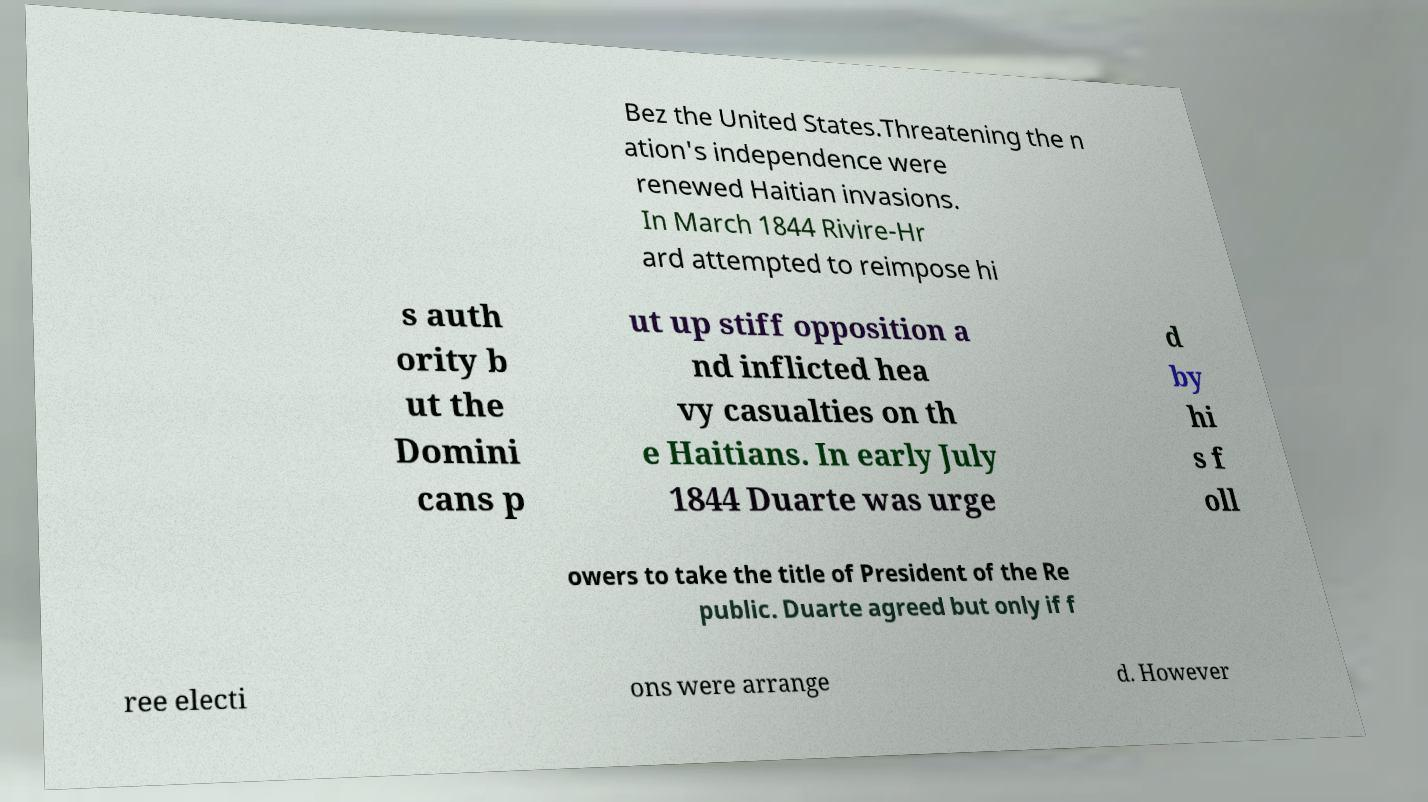For documentation purposes, I need the text within this image transcribed. Could you provide that? Bez the United States.Threatening the n ation's independence were renewed Haitian invasions. In March 1844 Rivire-Hr ard attempted to reimpose hi s auth ority b ut the Domini cans p ut up stiff opposition a nd inflicted hea vy casualties on th e Haitians. In early July 1844 Duarte was urge d by hi s f oll owers to take the title of President of the Re public. Duarte agreed but only if f ree electi ons were arrange d. However 